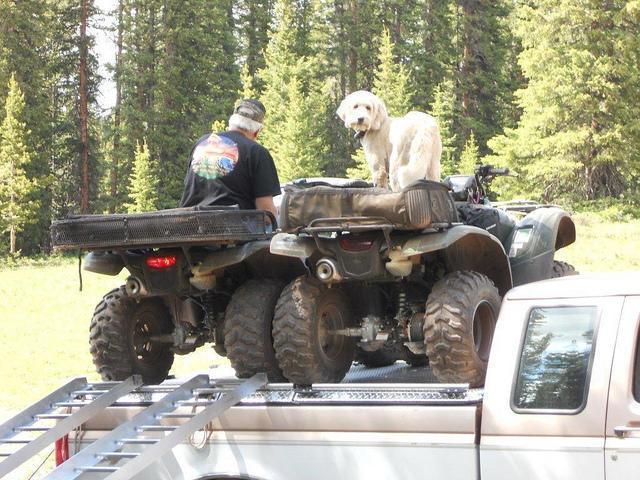How many people are there?
Give a very brief answer. 1. How many trucks are in the picture?
Give a very brief answer. 2. 